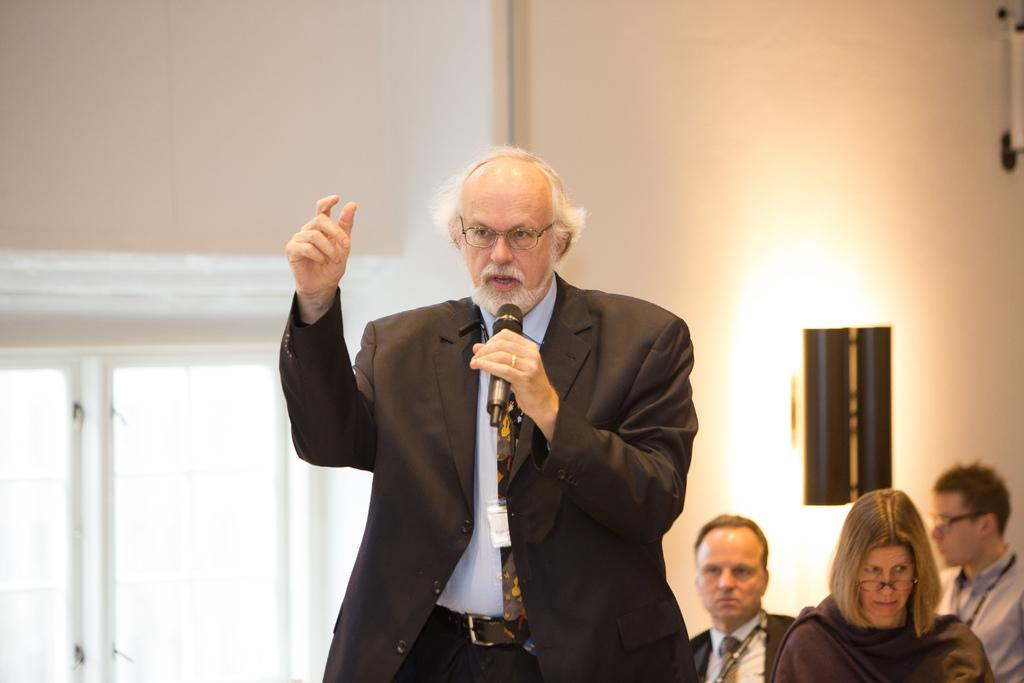What is the man in the image doing? The man is standing in the image and holding a microphone. Are there any other people in the image? Yes, there are other people sitting on a wall in the image. What can be seen in the background of the image? There is a window visible in the background of the image. What type of leather is being used to hold the egg on the tray in the image? There is no egg, leather, or tray present in the image. 